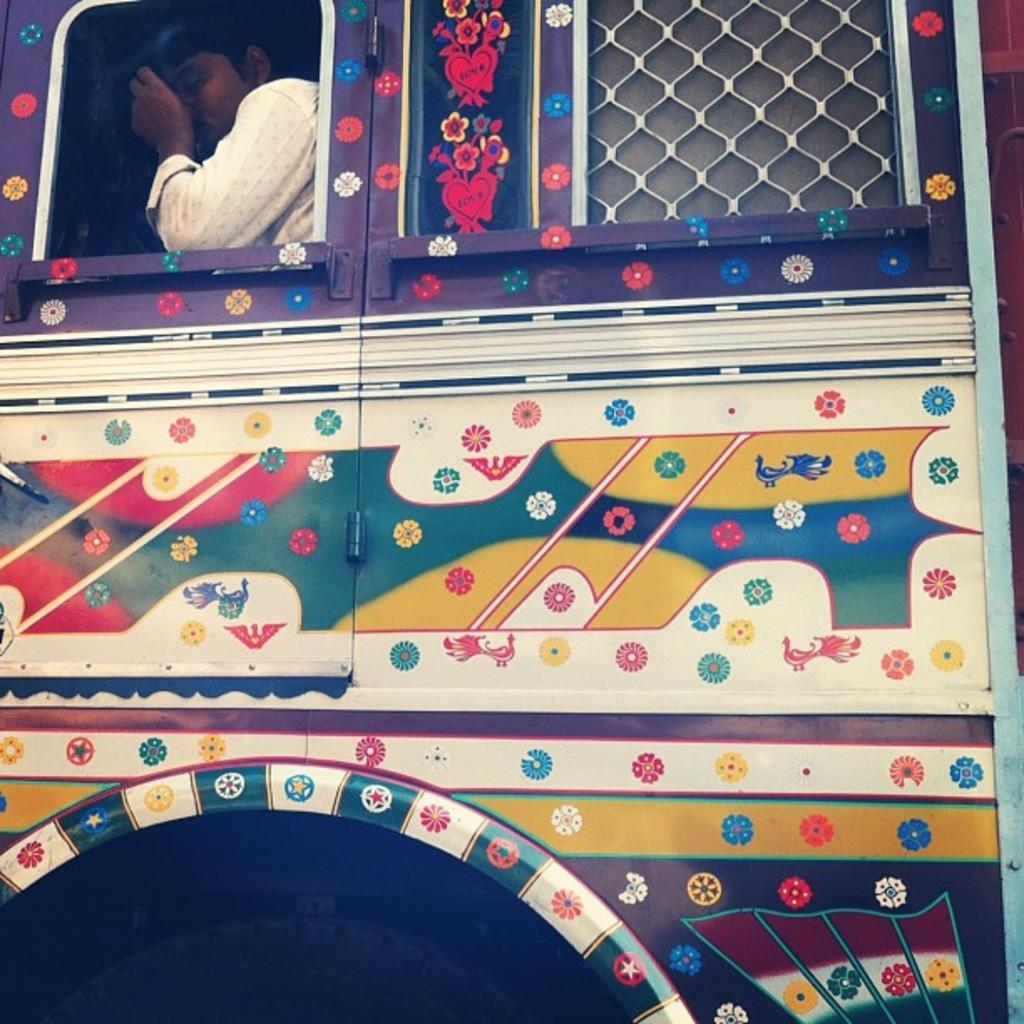Describe this image in one or two sentences. In this picture, we can see a person in a vehicle. 